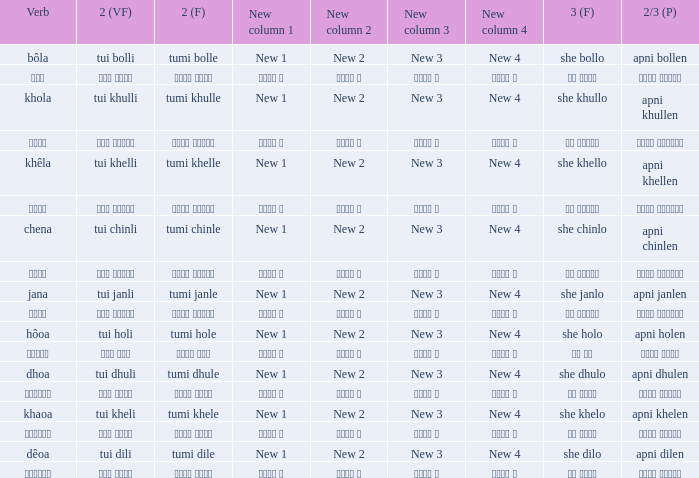What is the 2(vf) for তুমি বললে? তুই বললি. 